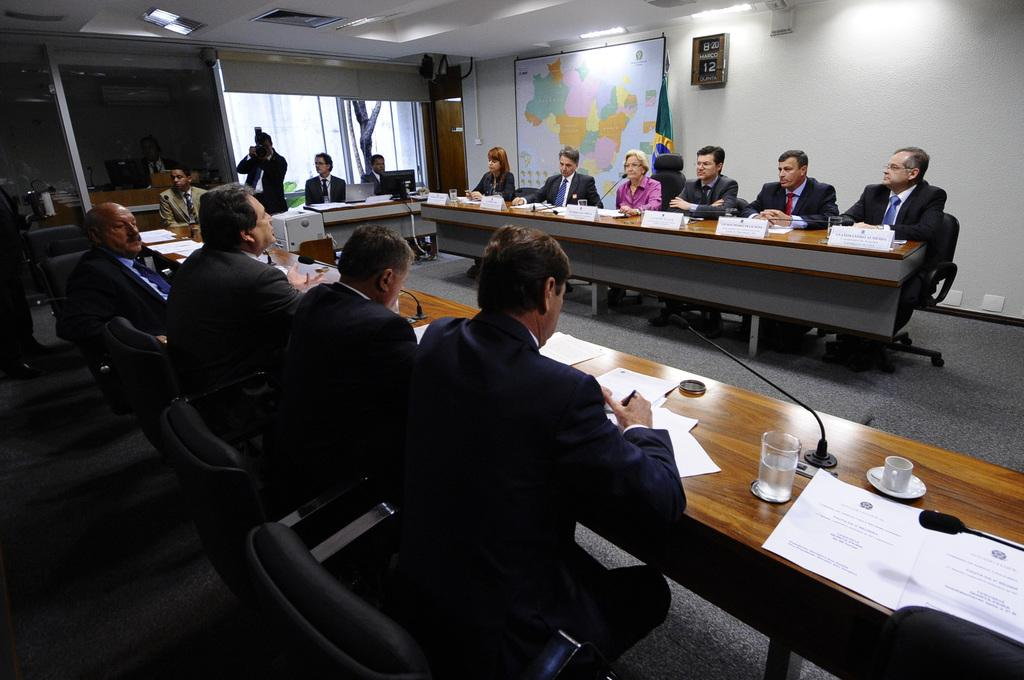How many people are in the image? There is a group of people in the image. What are the people doing in the image? The people are sitting on a chair. Can you identify any specific actions being performed by the people in the image? Yes, there is a person speaking and another person capturing in the image. What type of song is the person singing in the image? There is no indication in the image that a person is singing, so it cannot be determined from the picture. 